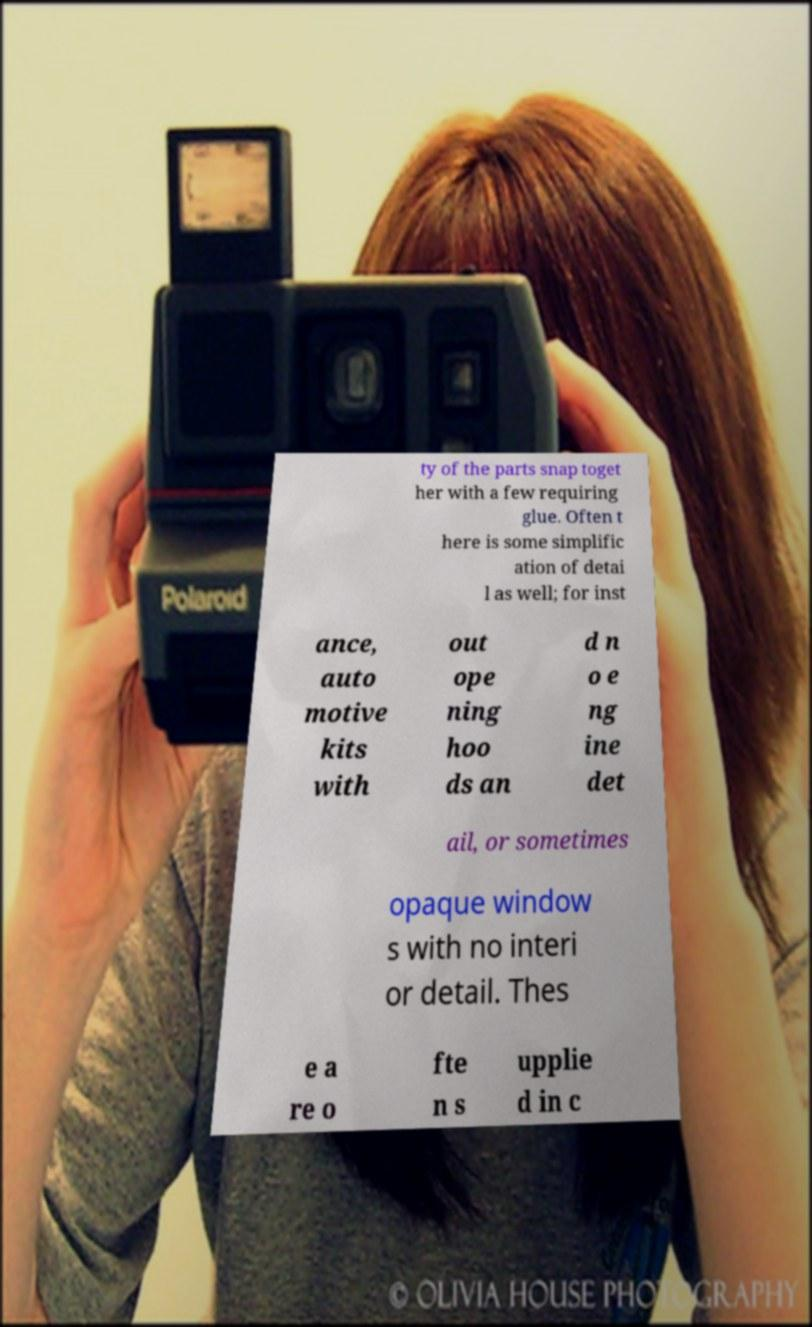Can you accurately transcribe the text from the provided image for me? ty of the parts snap toget her with a few requiring glue. Often t here is some simplific ation of detai l as well; for inst ance, auto motive kits with out ope ning hoo ds an d n o e ng ine det ail, or sometimes opaque window s with no interi or detail. Thes e a re o fte n s upplie d in c 